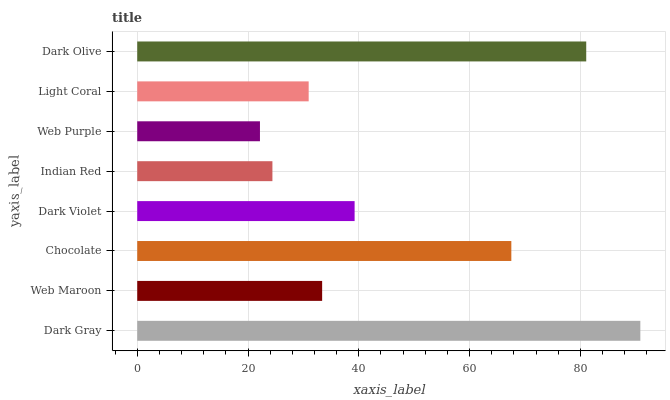Is Web Purple the minimum?
Answer yes or no. Yes. Is Dark Gray the maximum?
Answer yes or no. Yes. Is Web Maroon the minimum?
Answer yes or no. No. Is Web Maroon the maximum?
Answer yes or no. No. Is Dark Gray greater than Web Maroon?
Answer yes or no. Yes. Is Web Maroon less than Dark Gray?
Answer yes or no. Yes. Is Web Maroon greater than Dark Gray?
Answer yes or no. No. Is Dark Gray less than Web Maroon?
Answer yes or no. No. Is Dark Violet the high median?
Answer yes or no. Yes. Is Web Maroon the low median?
Answer yes or no. Yes. Is Light Coral the high median?
Answer yes or no. No. Is Web Purple the low median?
Answer yes or no. No. 